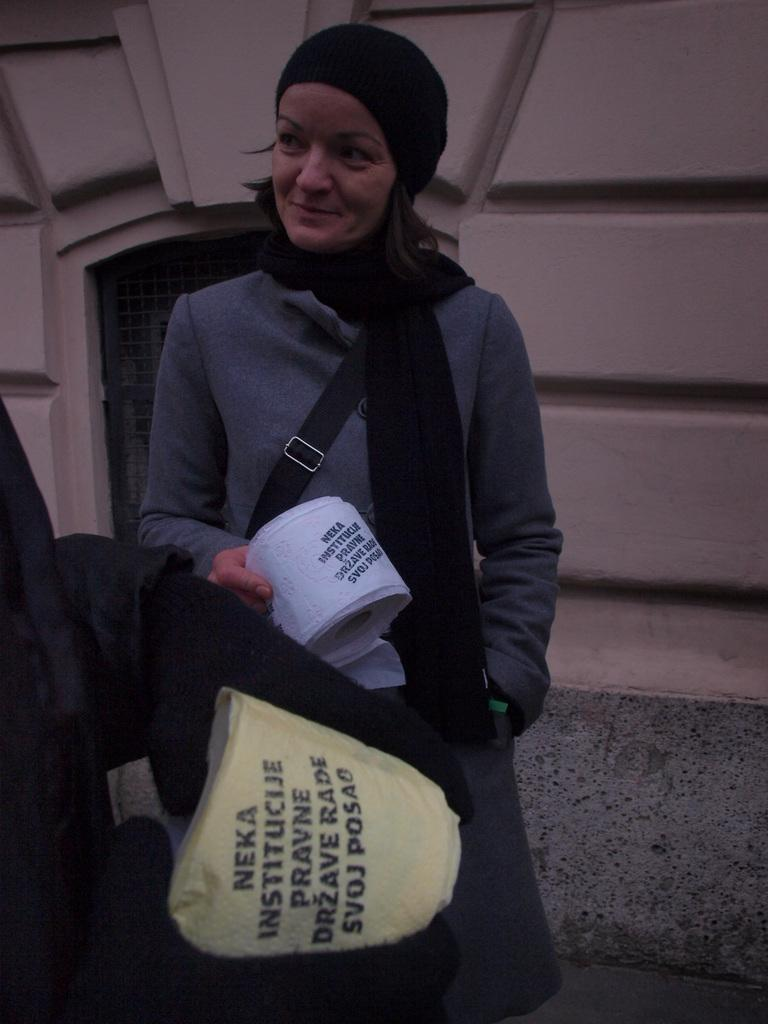What is the person in the image doing? The person is standing and holding an object in the image. Can you describe the position of the second person in the image? The second person is truncated towards the left of the image. What can be seen in the background of the image? There is a wall truncated in the background of the image. What type of rifle is the person holding in the image? There is no rifle present in the image; the person is holding an unspecified object. 